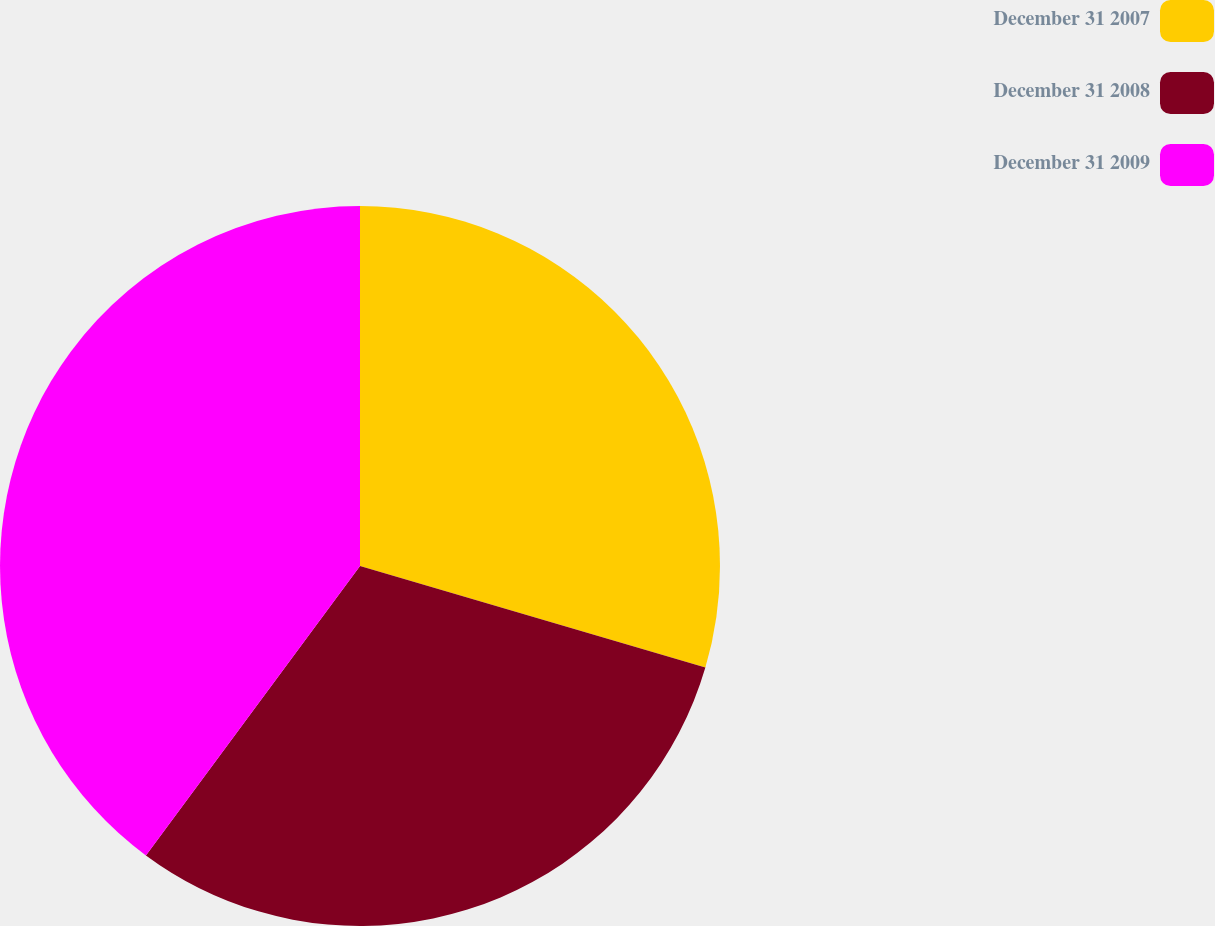Convert chart. <chart><loc_0><loc_0><loc_500><loc_500><pie_chart><fcel>December 31 2007<fcel>December 31 2008<fcel>December 31 2009<nl><fcel>29.55%<fcel>30.58%<fcel>39.86%<nl></chart> 